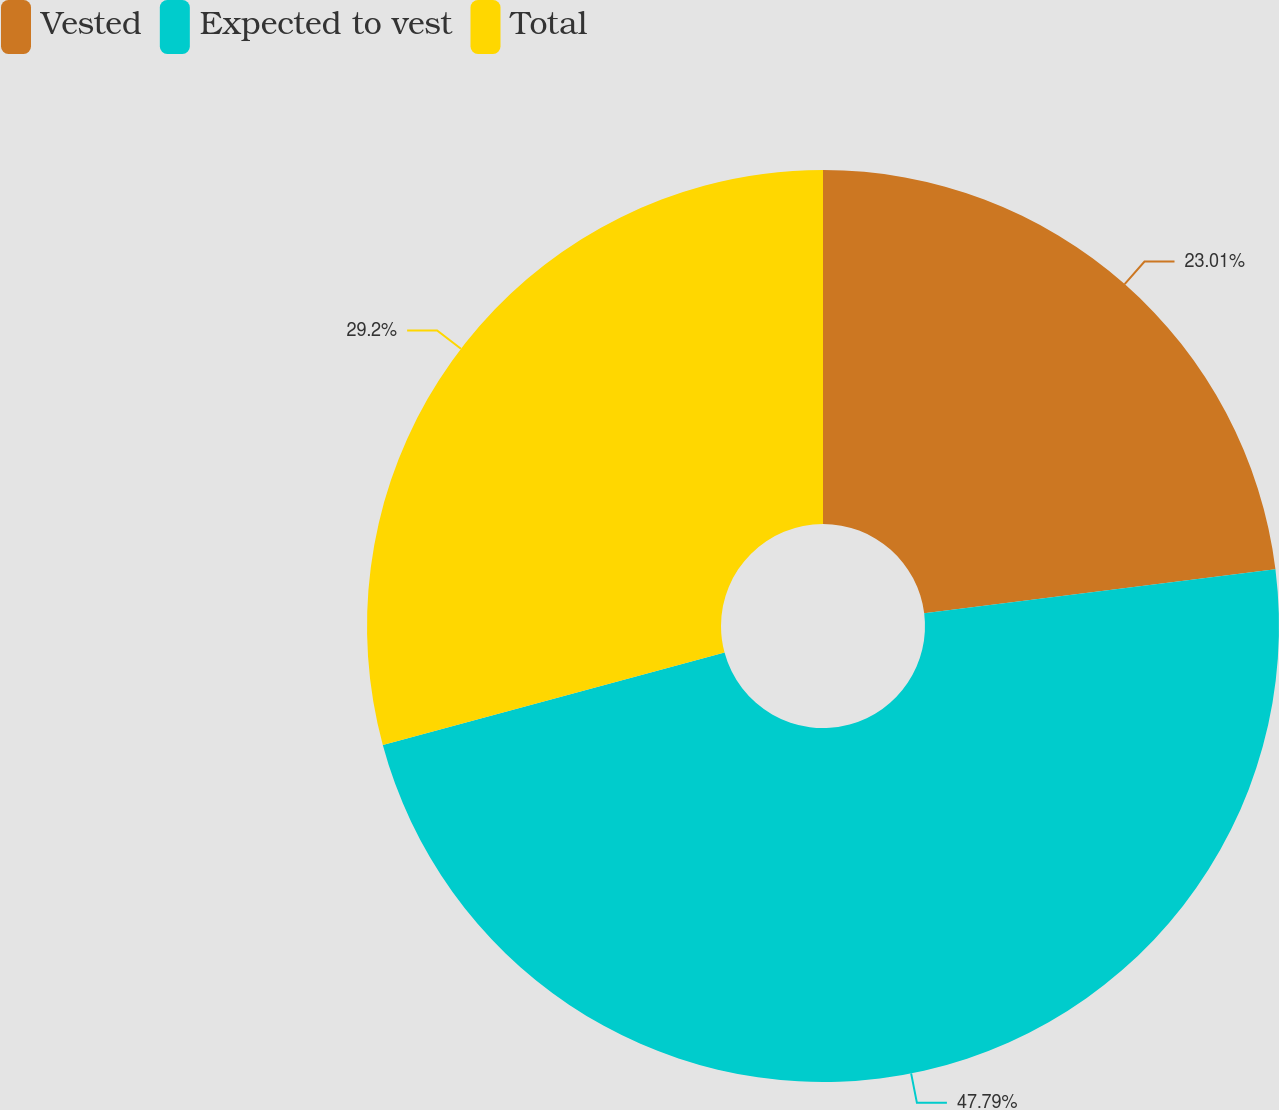Convert chart to OTSL. <chart><loc_0><loc_0><loc_500><loc_500><pie_chart><fcel>Vested<fcel>Expected to vest<fcel>Total<nl><fcel>23.01%<fcel>47.79%<fcel>29.2%<nl></chart> 